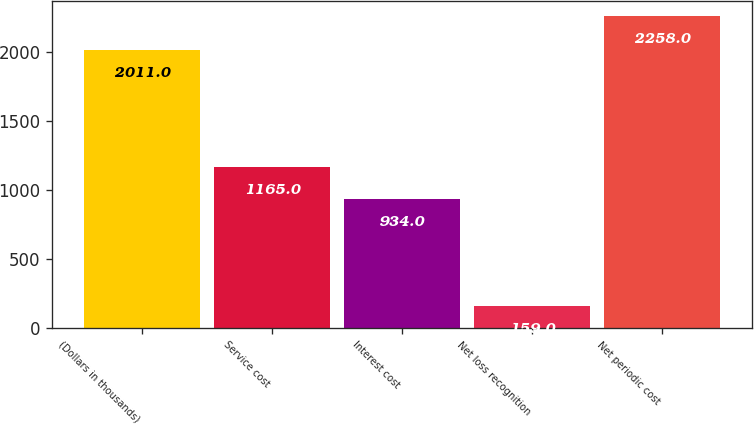Convert chart to OTSL. <chart><loc_0><loc_0><loc_500><loc_500><bar_chart><fcel>(Dollars in thousands)<fcel>Service cost<fcel>Interest cost<fcel>Net loss recognition<fcel>Net periodic cost<nl><fcel>2011<fcel>1165<fcel>934<fcel>159<fcel>2258<nl></chart> 